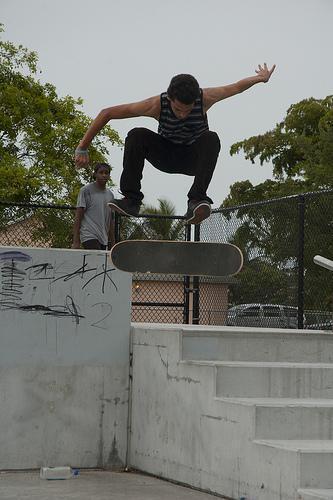How many people are in the photo?
Give a very brief answer. 2. 